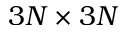Convert formula to latex. <formula><loc_0><loc_0><loc_500><loc_500>3 N \times 3 N</formula> 